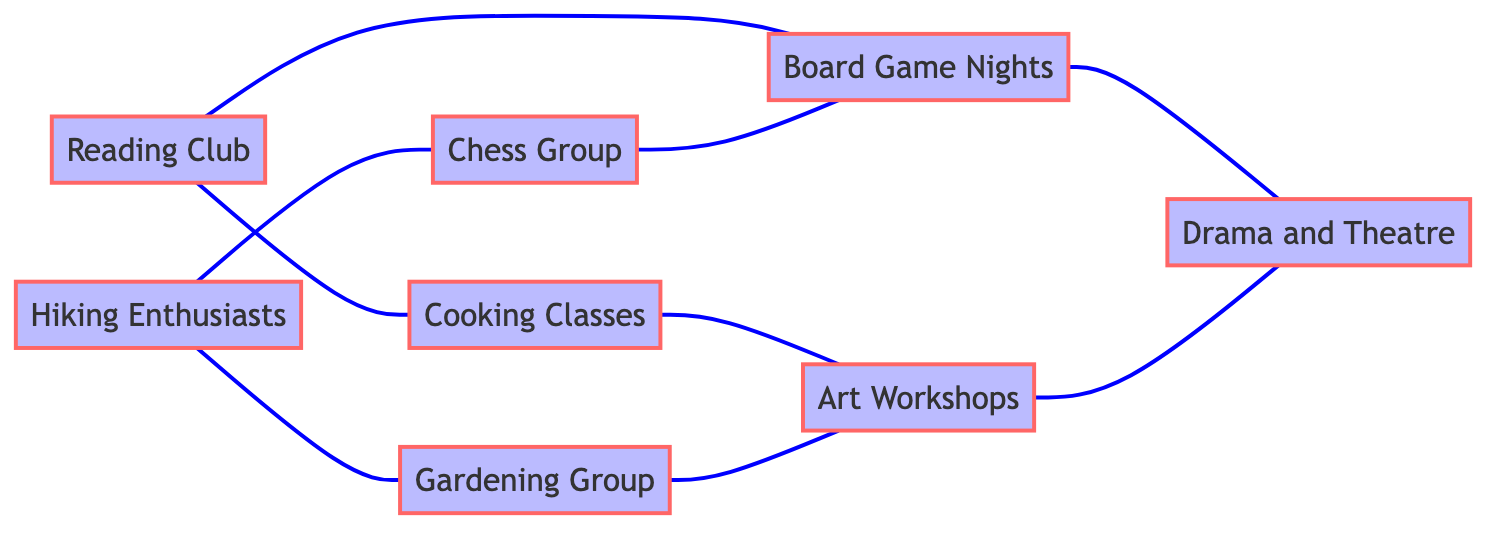What is the total number of activities represented in the diagram? The diagram has a total of 8 nodes, each representing a unique activity in the community group.
Answer: 8 Which activity is connected to both the Reading Club and the Board Game Nights? The node for Cooking Classes is directly connected to the Reading Club and indirectly connected to the Board Game Nights through the Reading Club and the Chess Group. This interconnectivity indicates that they share interests or activities facilitated through both.
Answer: Cooking Classes How many connections does the Gardening Group have? The Gardening Group is connected to two activities: Hiking Enthusiasts and Art Workshops, which counts as two edges connected to it in the diagram.
Answer: 2 Which two activities share the most connections? The Art Workshops and Drama and Theatre are interconnected through three total edges, which involves their own connections plus the shared connection with Board Game Nights. This implies they are closely related in multiple ways.
Answer: Art Workshops and Drama and Theatre How many activities are connected to the Hiking Enthusiasts? The Hiking Enthusiasts are connected to two activities: Chess Group and Gardening Group. This totals the number of direct connections from it in the diagram.
Answer: 2 Which activities are connected to Board Game Nights? The Board Game Nights have edges connecting to both Reading Club and Drama and Theatre, making a total of two activities directly linked to it.
Answer: Reading Club and Drama and Theatre Are there any activities that share connections with both Chess Group and Cooking Classes? Both Chess Group and Cooking Classes are connected to Board Game Nights, making it possible for a shared activity between them through this common connection.
Answer: Yes, Board Game Nights What is the relationship between the Cooking Classes and Art Workshops? Cooking Classes do not have a direct edge linking them to Art Workshops; instead, they are indirectly connected through two other groups, making it a non-direct relationship.
Answer: No direct connection 